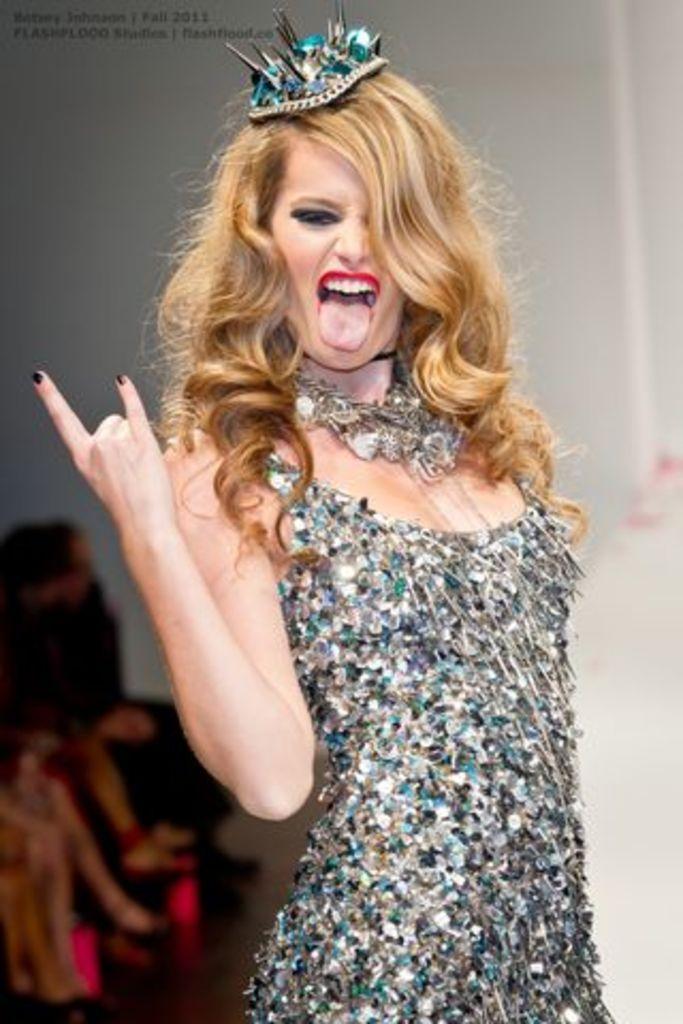Describe this image in one or two sentences. In the picture we can see a woman standing and giving an expression with a hand and tongue and she has a brown curly hair and a crown with some lines to it and behind we can see a wall. 